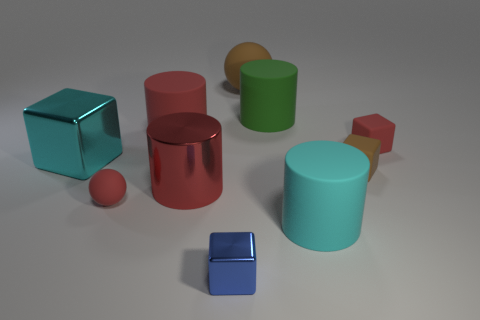Subtract all spheres. How many objects are left? 8 Add 2 big red objects. How many big red objects exist? 4 Subtract 0 green balls. How many objects are left? 10 Subtract all big metallic cylinders. Subtract all shiny blocks. How many objects are left? 7 Add 4 cyan rubber cylinders. How many cyan rubber cylinders are left? 5 